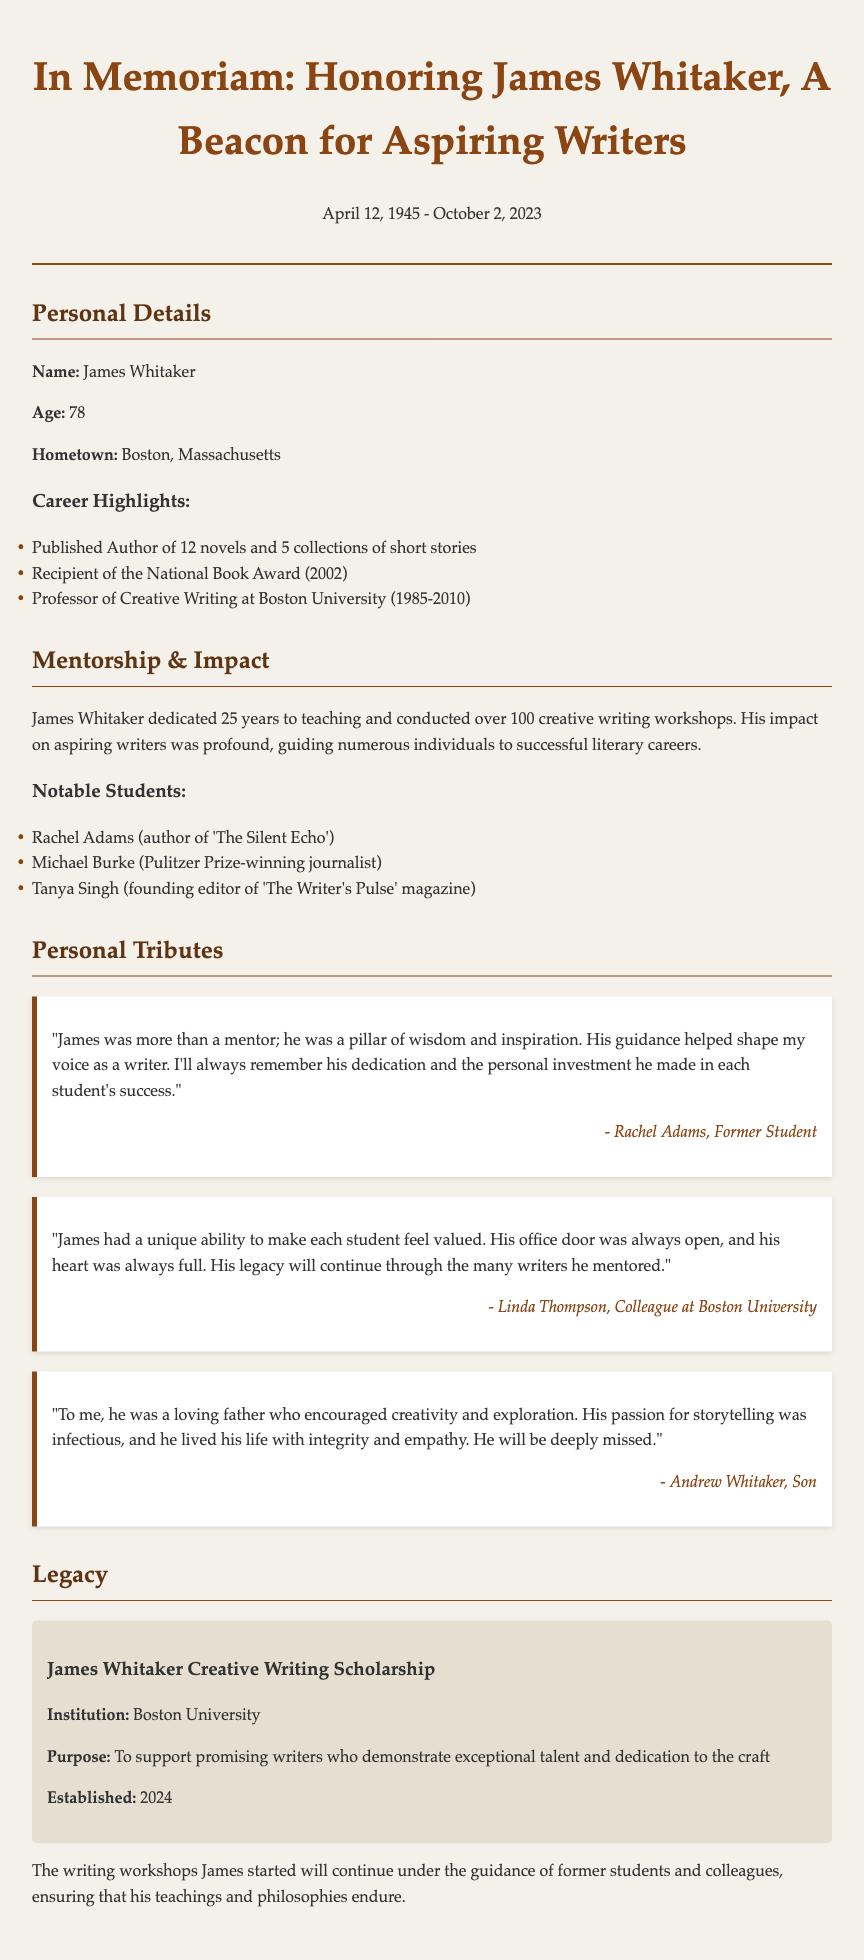what is the full name of the person honored in the obituary? The document specifies the name of the person being honored as James Whitaker.
Answer: James Whitaker what was James Whitaker's age at the time of his passing? The obituary states that James Whitaker was 78 years old when he passed away.
Answer: 78 which university did James Whitaker work for as a professor? The document indicates that he was a professor at Boston University.
Answer: Boston University how many novels did James Whitaker publish? The document lists 12 novels published by James Whitaker.
Answer: 12 what is the name of a notable student mentioned in the document? The document names Rachel Adams as a notable student among others.
Answer: Rachel Adams what award did James Whitaker receive in 2002? The document notes that he received the National Book Award in 2002.
Answer: National Book Award how long did James Whitaker dedicate to teaching? The document specifies that he dedicated 25 years to teaching.
Answer: 25 years what title did they give to the scholarship established in his memory? The document refers to the scholarship as the James Whitaker Creative Writing Scholarship.
Answer: James Whitaker Creative Writing Scholarship what is the purpose of the James Whitaker Creative Writing Scholarship? The document states the purpose is to support promising writers demonstrating exceptional talent.
Answer: To support promising writers 